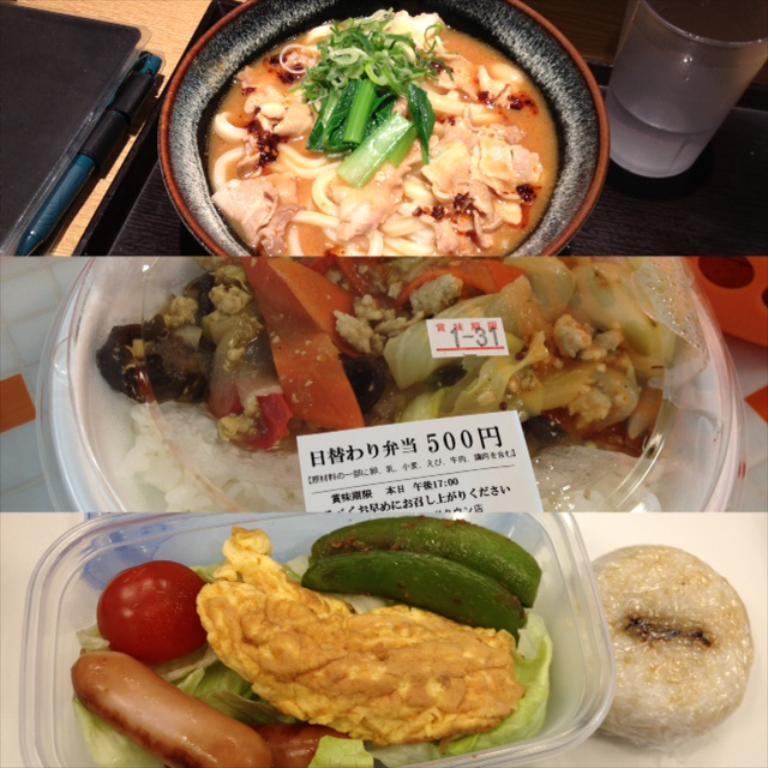Please provide a concise description of this image. This is collage picture, in these pictures we can see food, bowls, glass with drink and objects. 